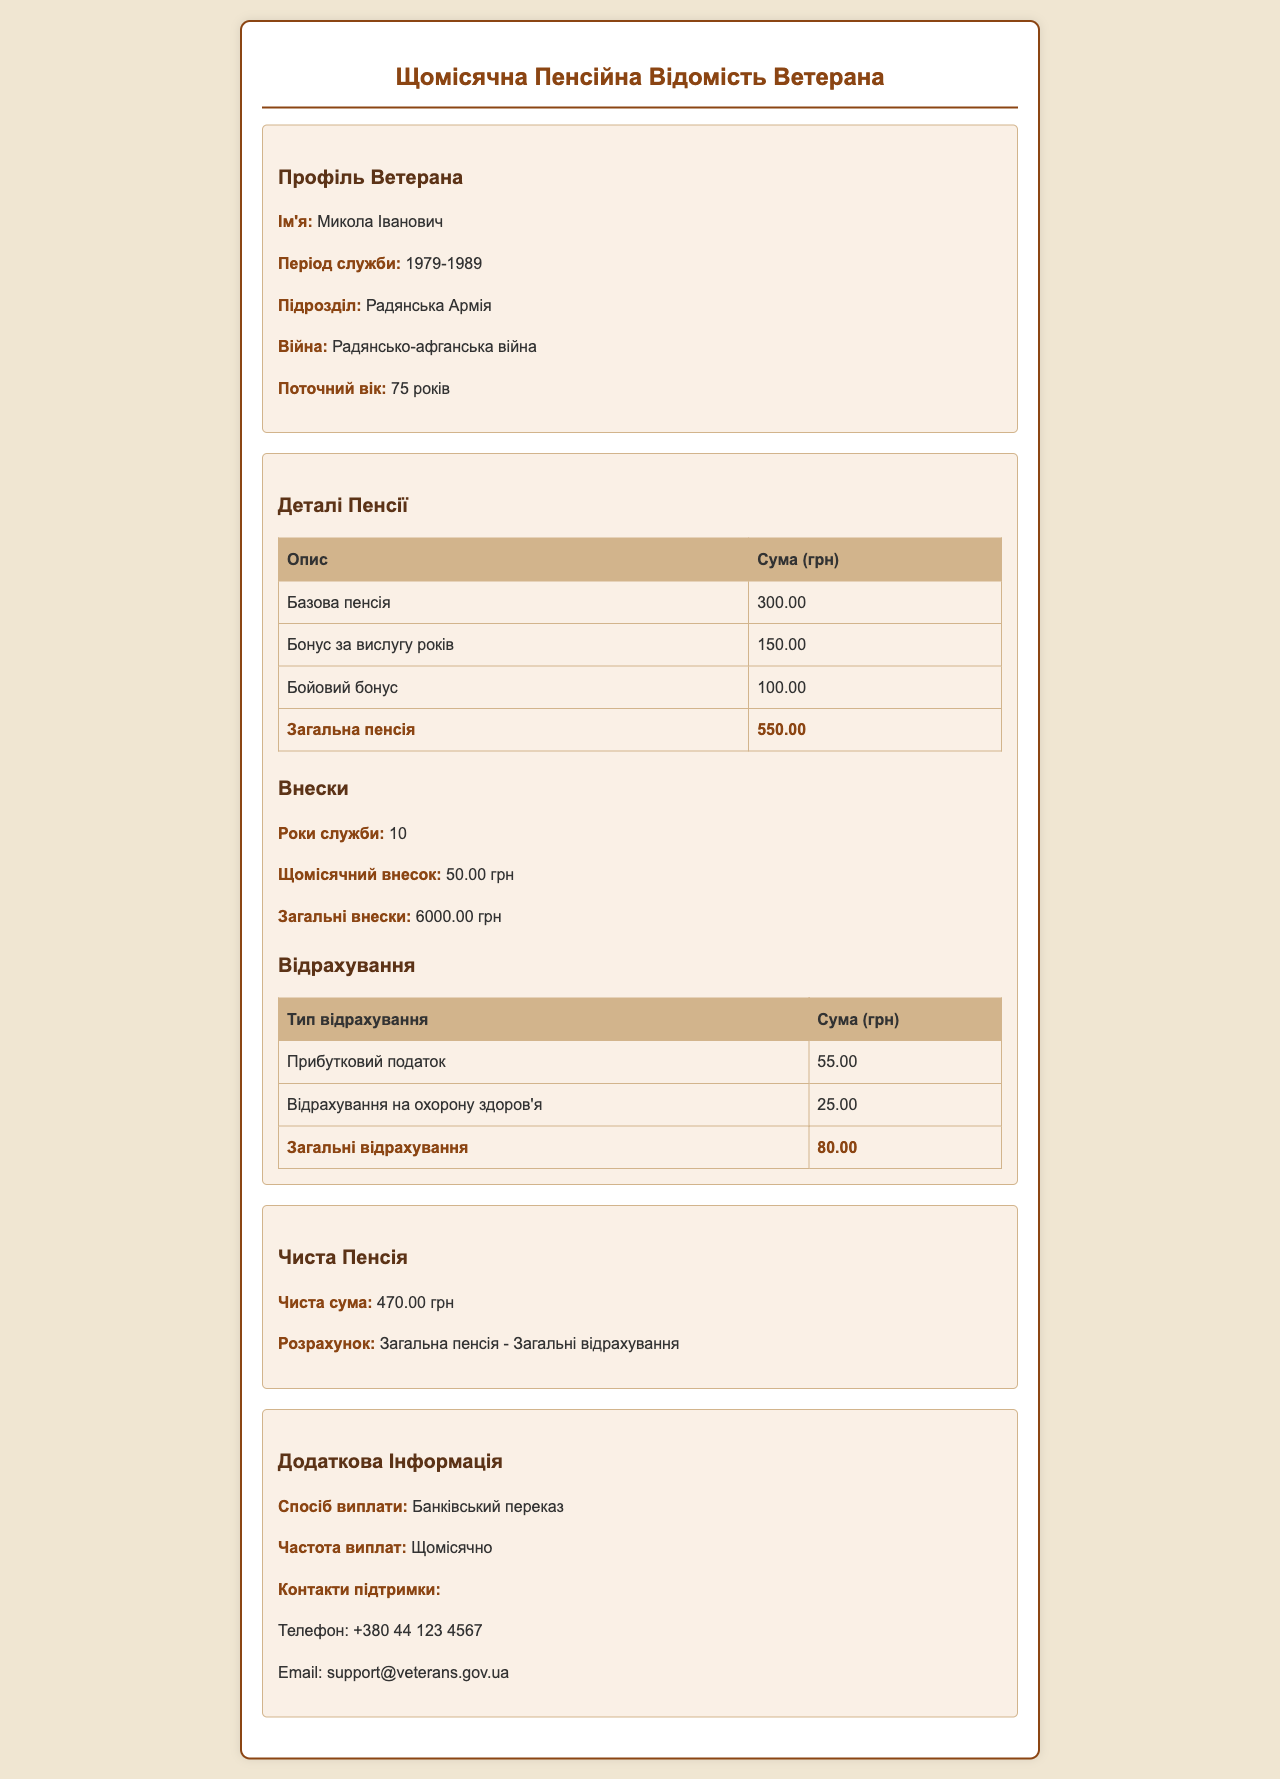What is the veteran's name? The veteran's name is mentioned in the profile section of the document.
Answer: Микола Іванович What period did the veteran serve? The period of service is indicated under the veteran's profile.
Answer: 1979-1989 What is the total pension amount? The total pension is calculated from the pension details section.
Answer: 550.00 How much is the monthly contribution? The monthly contribution amount is specified in the contributions section.
Answer: 50.00 грн What are the total deductions? The total deductions are summarized in the deductions table at the end of the section.
Answer: 80.00 What is the net pension amount? The net pension amount is provided in the net pension section.
Answer: 470.00 грн How often are the pensions paid? The frequency of the payments is mentioned in the additional information section.
Answer: Щомісячно What type of payment method is used? The method of payment is stated in the additional information section.
Answer: Банківський переказ Who can be contacted for support? The contact information for support is provided in the additional information section.
Answer: Телефон: +380 44 123 4567 